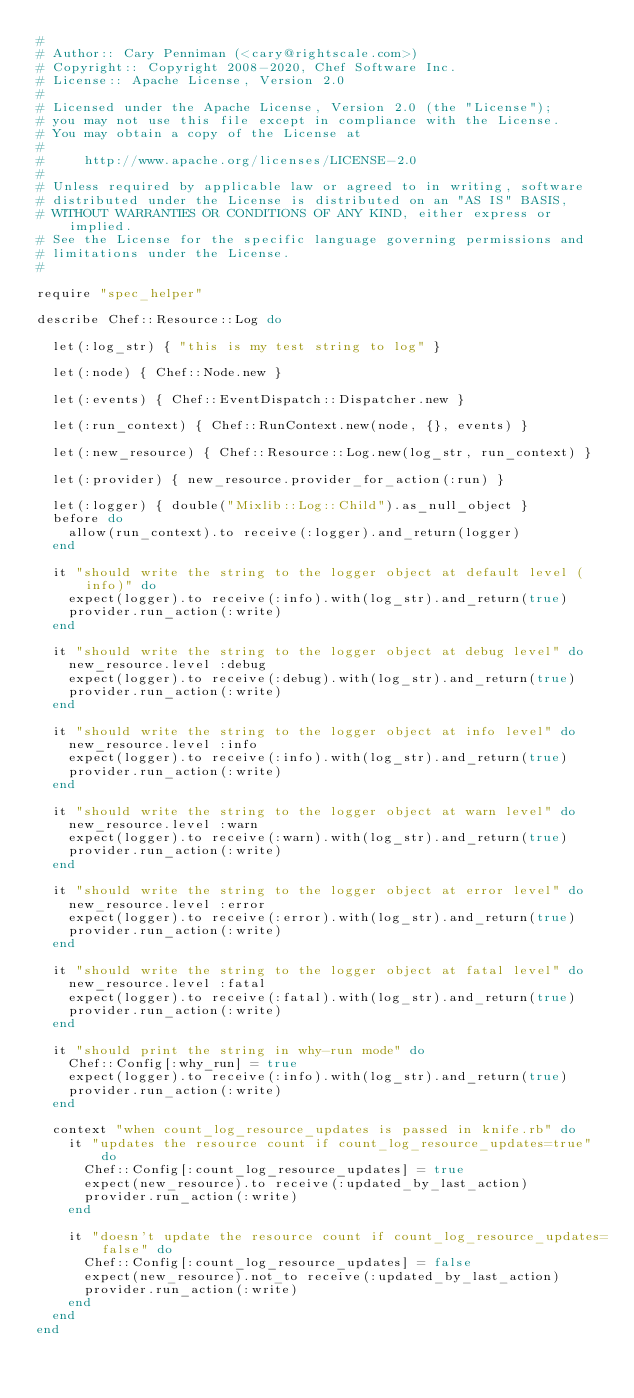Convert code to text. <code><loc_0><loc_0><loc_500><loc_500><_Ruby_>#
# Author:: Cary Penniman (<cary@rightscale.com>)
# Copyright:: Copyright 2008-2020, Chef Software Inc.
# License:: Apache License, Version 2.0
#
# Licensed under the Apache License, Version 2.0 (the "License");
# you may not use this file except in compliance with the License.
# You may obtain a copy of the License at
#
#     http://www.apache.org/licenses/LICENSE-2.0
#
# Unless required by applicable law or agreed to in writing, software
# distributed under the License is distributed on an "AS IS" BASIS,
# WITHOUT WARRANTIES OR CONDITIONS OF ANY KIND, either express or implied.
# See the License for the specific language governing permissions and
# limitations under the License.
#

require "spec_helper"

describe Chef::Resource::Log do

  let(:log_str) { "this is my test string to log" }

  let(:node) { Chef::Node.new }

  let(:events) { Chef::EventDispatch::Dispatcher.new }

  let(:run_context) { Chef::RunContext.new(node, {}, events) }

  let(:new_resource) { Chef::Resource::Log.new(log_str, run_context) }

  let(:provider) { new_resource.provider_for_action(:run) }

  let(:logger) { double("Mixlib::Log::Child").as_null_object }
  before do
    allow(run_context).to receive(:logger).and_return(logger)
  end

  it "should write the string to the logger object at default level (info)" do
    expect(logger).to receive(:info).with(log_str).and_return(true)
    provider.run_action(:write)
  end

  it "should write the string to the logger object at debug level" do
    new_resource.level :debug
    expect(logger).to receive(:debug).with(log_str).and_return(true)
    provider.run_action(:write)
  end

  it "should write the string to the logger object at info level" do
    new_resource.level :info
    expect(logger).to receive(:info).with(log_str).and_return(true)
    provider.run_action(:write)
  end

  it "should write the string to the logger object at warn level" do
    new_resource.level :warn
    expect(logger).to receive(:warn).with(log_str).and_return(true)
    provider.run_action(:write)
  end

  it "should write the string to the logger object at error level" do
    new_resource.level :error
    expect(logger).to receive(:error).with(log_str).and_return(true)
    provider.run_action(:write)
  end

  it "should write the string to the logger object at fatal level" do
    new_resource.level :fatal
    expect(logger).to receive(:fatal).with(log_str).and_return(true)
    provider.run_action(:write)
  end

  it "should print the string in why-run mode" do
    Chef::Config[:why_run] = true
    expect(logger).to receive(:info).with(log_str).and_return(true)
    provider.run_action(:write)
  end

  context "when count_log_resource_updates is passed in knife.rb" do
    it "updates the resource count if count_log_resource_updates=true" do
      Chef::Config[:count_log_resource_updates] = true
      expect(new_resource).to receive(:updated_by_last_action)
      provider.run_action(:write)
    end

    it "doesn't update the resource count if count_log_resource_updates=false" do
      Chef::Config[:count_log_resource_updates] = false
      expect(new_resource).not_to receive(:updated_by_last_action)
      provider.run_action(:write)
    end
  end
end
</code> 